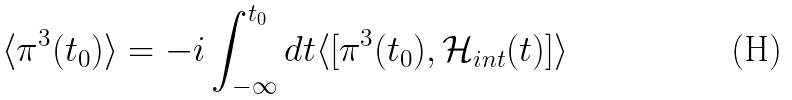<formula> <loc_0><loc_0><loc_500><loc_500>\langle \pi ^ { 3 } ( t _ { 0 } ) \rangle = - i \int _ { - \infty } ^ { t _ { 0 } } d t \langle [ \pi ^ { 3 } ( t _ { 0 } ) , { \mathcal { H } } _ { i n t } ( t ) ] \rangle</formula> 